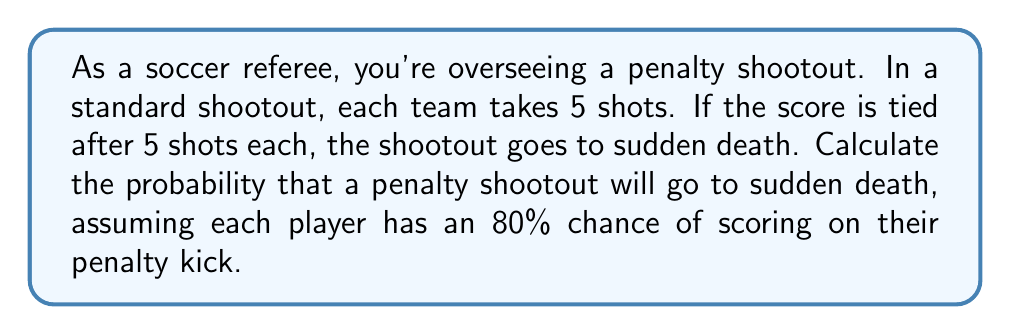Can you solve this math problem? Let's approach this step-by-step:

1) For the shootout to go to sudden death, both teams must have the same score after 5 shots each.

2) We can calculate this by finding the probability of each possible tied score (0-0, 1-1, 2-2, 3-3, 4-4, 5-5) and summing these probabilities.

3) For each shot, the probability of scoring is 0.8 and missing is 0.2.

4) For a score of x-x after 5 shots each, we need:
   - x successful shots out of 5 for team A
   - x successful shots out of 5 for team B

5) This can be calculated using the binomial probability formula:

   $$P(X = x) = \binom{n}{x} p^x (1-p)^{n-x}$$

   Where $n = 5$, $p = 0.8$, and $x$ ranges from 0 to 5.

6) The probability for each tied score is:

   $$P(\text{x-x}) = P(X_A = x) \cdot P(X_B = x) = \left[\binom{5}{x} 0.8^x 0.2^{5-x}\right]^2$$

7) Calculating for each x:

   0-0: $\left[\binom{5}{0} 0.8^0 0.2^5\right]^2 = 0.00000256$
   1-1: $\left[\binom{5}{1} 0.8^1 0.2^4\right]^2 = 0.00020480$
   2-2: $\left[\binom{5}{2} 0.8^2 0.2^3\right]^2 = 0.00327680$
   3-3: $\left[\binom{5}{3} 0.8^3 0.2^2\right]^2 = 0.01747200$
   4-4: $\left[\binom{5}{4} 0.8^4 0.2^1\right]^2 = 0.03145728$
   5-5: $\left[\binom{5}{5} 0.8^5 0.2^0\right]^2 = 0.01048576$

8) The total probability is the sum of these individual probabilities:

   $$0.00000256 + 0.00020480 + 0.00327680 + 0.01747200 + 0.03145728 + 0.01048576 = 0.06289920$$
Answer: The probability that a penalty shootout will go to sudden death is approximately 0.0629 or 6.29%. 